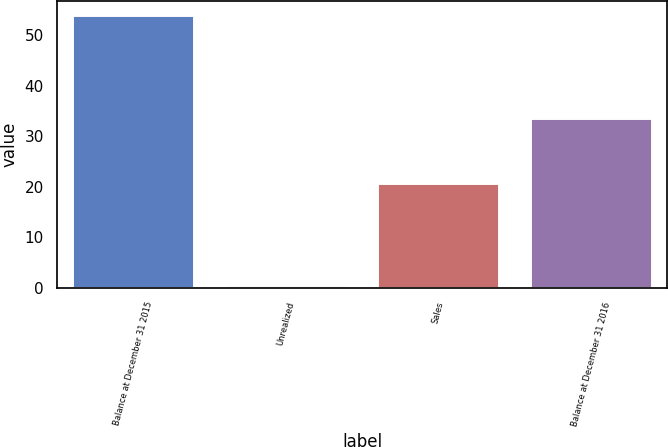Convert chart. <chart><loc_0><loc_0><loc_500><loc_500><bar_chart><fcel>Balance at December 31 2015<fcel>Unrealized<fcel>Sales<fcel>Balance at December 31 2016<nl><fcel>54<fcel>0.5<fcel>20.8<fcel>33.7<nl></chart> 